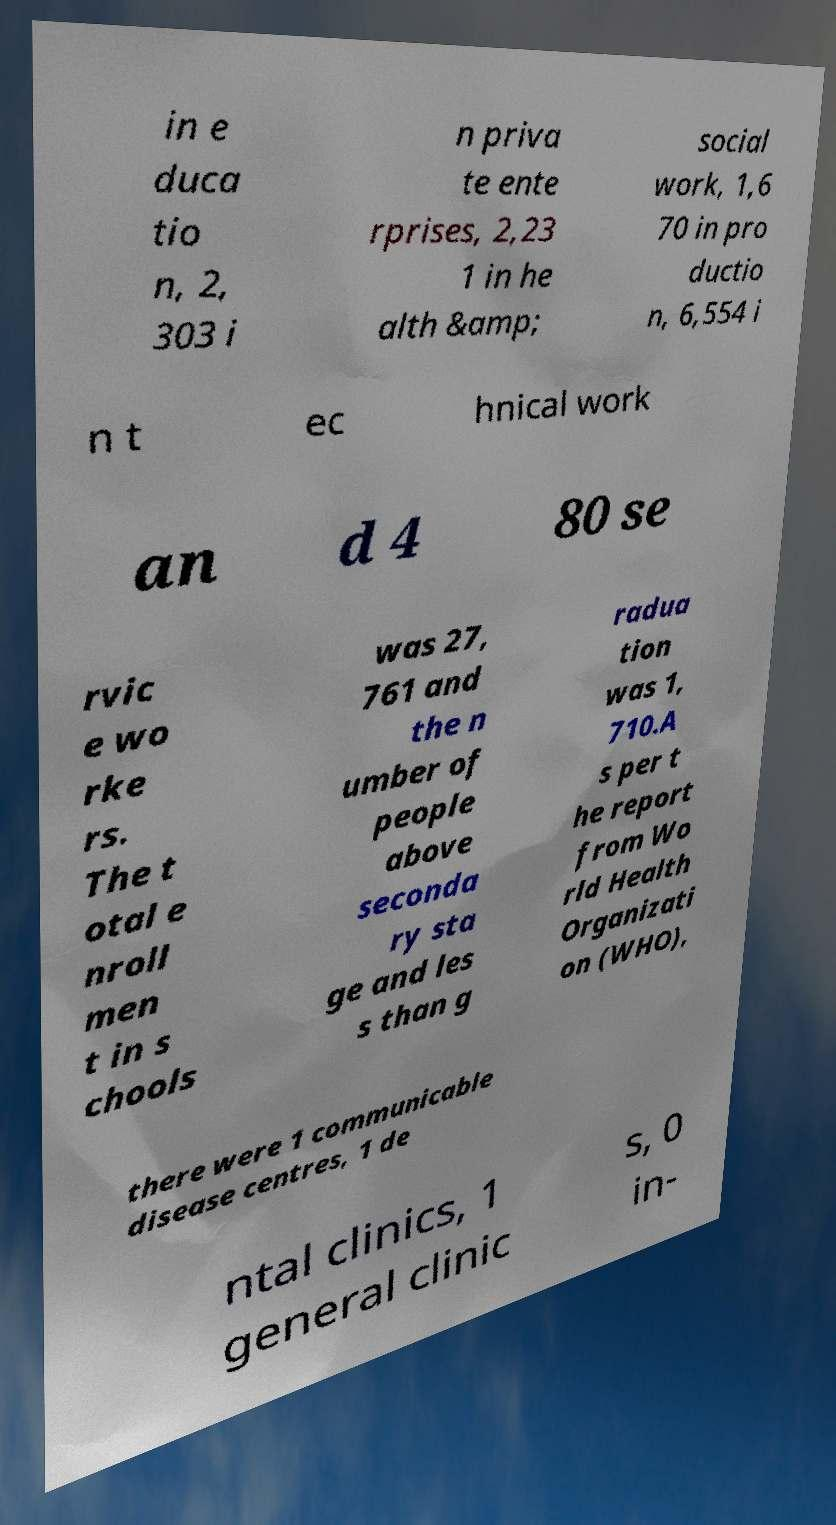Could you extract and type out the text from this image? in e duca tio n, 2, 303 i n priva te ente rprises, 2,23 1 in he alth &amp; social work, 1,6 70 in pro ductio n, 6,554 i n t ec hnical work an d 4 80 se rvic e wo rke rs. The t otal e nroll men t in s chools was 27, 761 and the n umber of people above seconda ry sta ge and les s than g radua tion was 1, 710.A s per t he report from Wo rld Health Organizati on (WHO), there were 1 communicable disease centres, 1 de ntal clinics, 1 general clinic s, 0 in- 